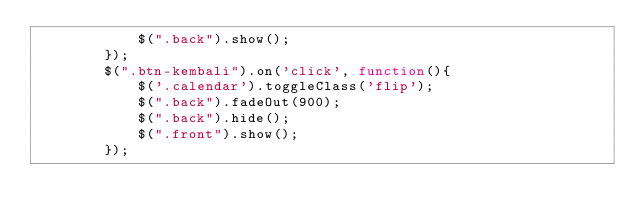Convert code to text. <code><loc_0><loc_0><loc_500><loc_500><_JavaScript_>            $(".back").show();
        });
        $(".btn-kembali").on('click', function(){
            $('.calendar').toggleClass('flip');
            $(".back").fadeOut(900);
            $(".back").hide();
            $(".front").show();
        });</code> 